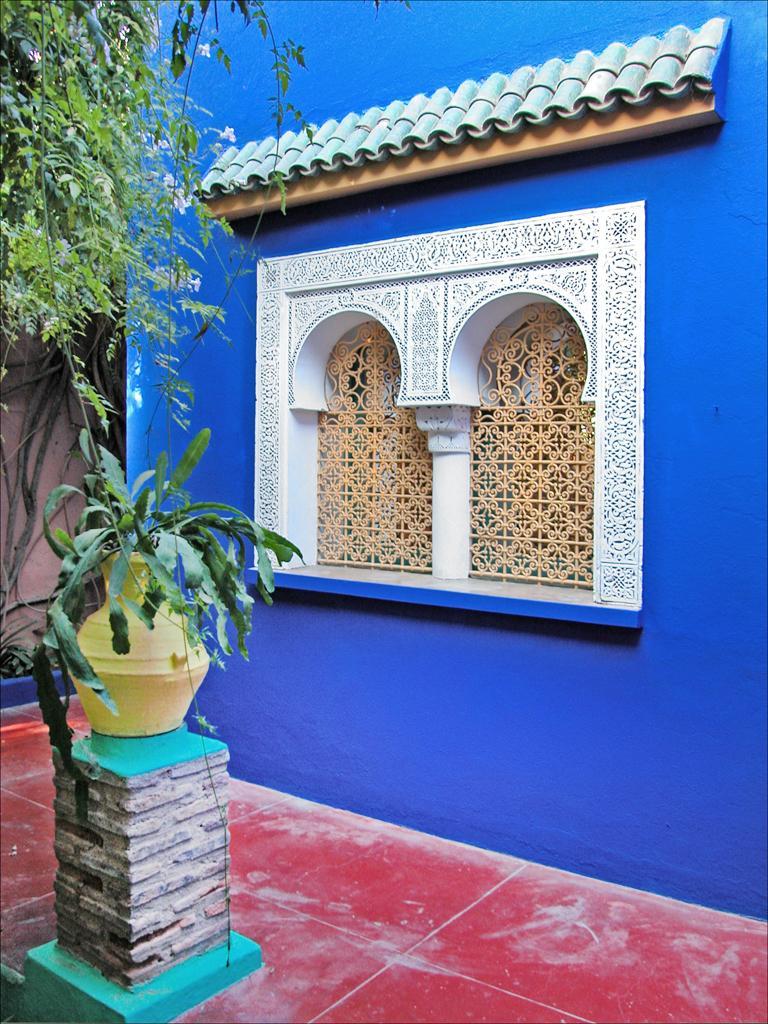Can you describe this image briefly? In this picture we can see blue color wall, few plants, flowers and tree, at the bottom of the image we can see red color floor. 